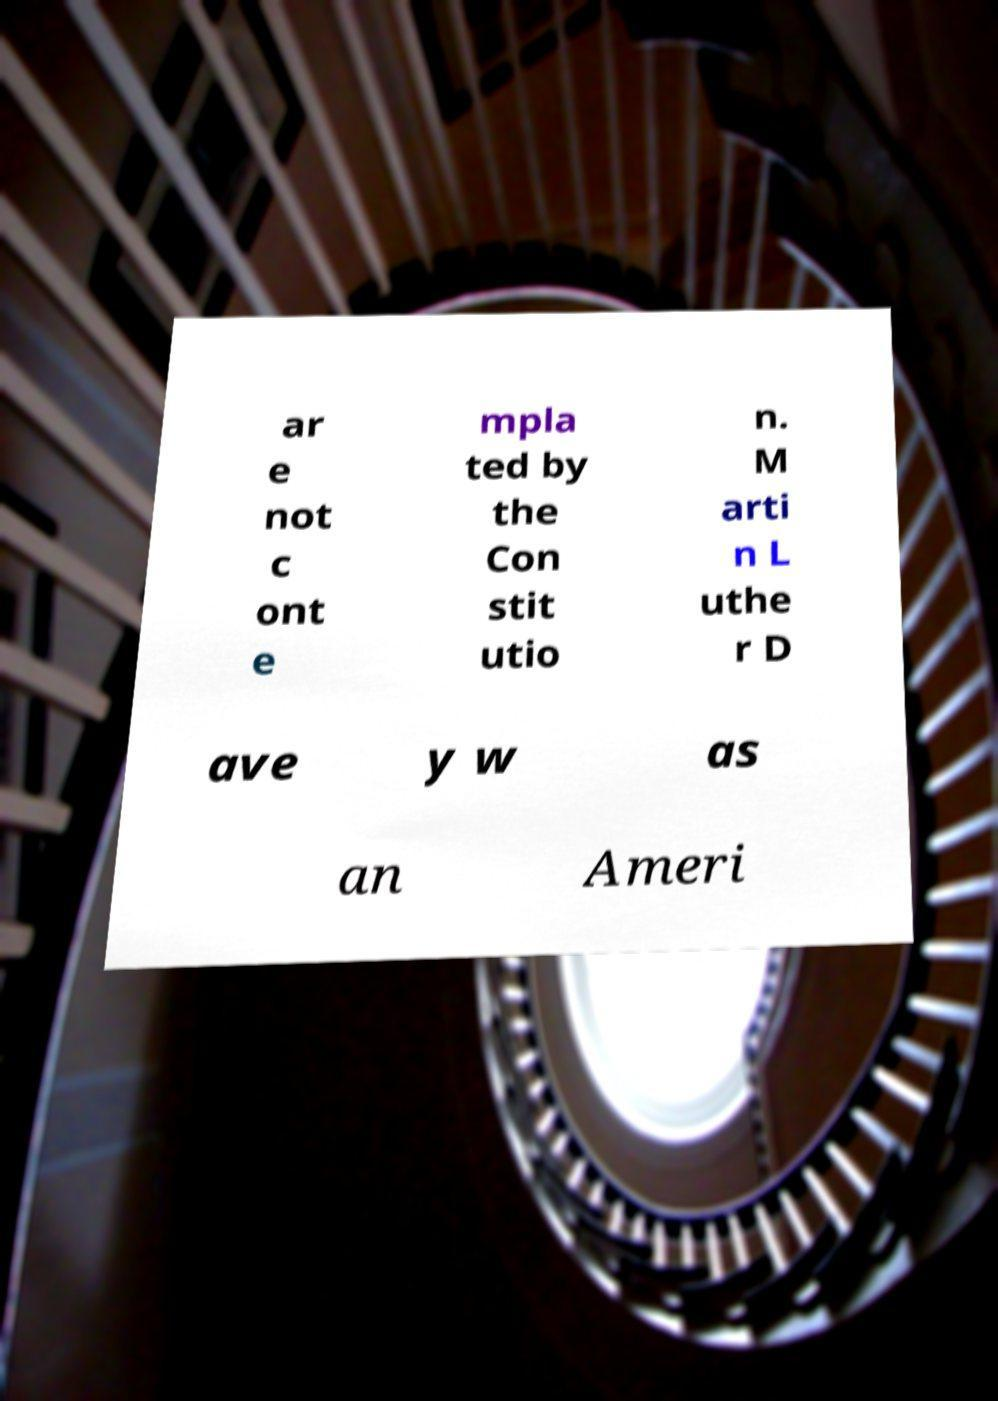Please identify and transcribe the text found in this image. ar e not c ont e mpla ted by the Con stit utio n. M arti n L uthe r D ave y w as an Ameri 